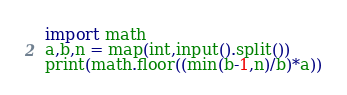Convert code to text. <code><loc_0><loc_0><loc_500><loc_500><_Python_>import math
a,b,n = map(int,input().split())
print(math.floor((min(b-1,n)/b)*a))
</code> 